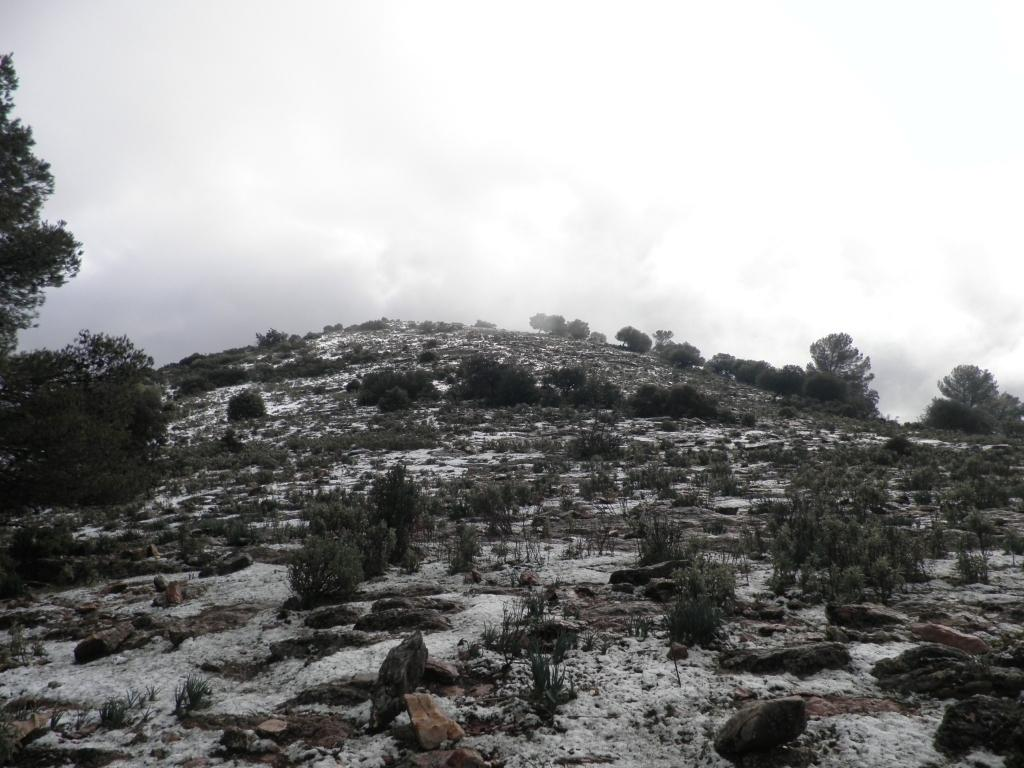What is the main subject of the image? The main subject of the image is a group of plants and trees on a hill. What can be seen in the foreground of the image? There are rocks in the foreground of the image. What is visible in the background of the image? The sky is visible in the background of the image. How would you describe the sky in the image? The sky appears to be cloudy in the image. What type of cable can be seen connecting the plants and trees in the image? There is no cable present in the image; it features a group of plants and trees on a hill with rocks in the foreground and a cloudy sky in the background. 